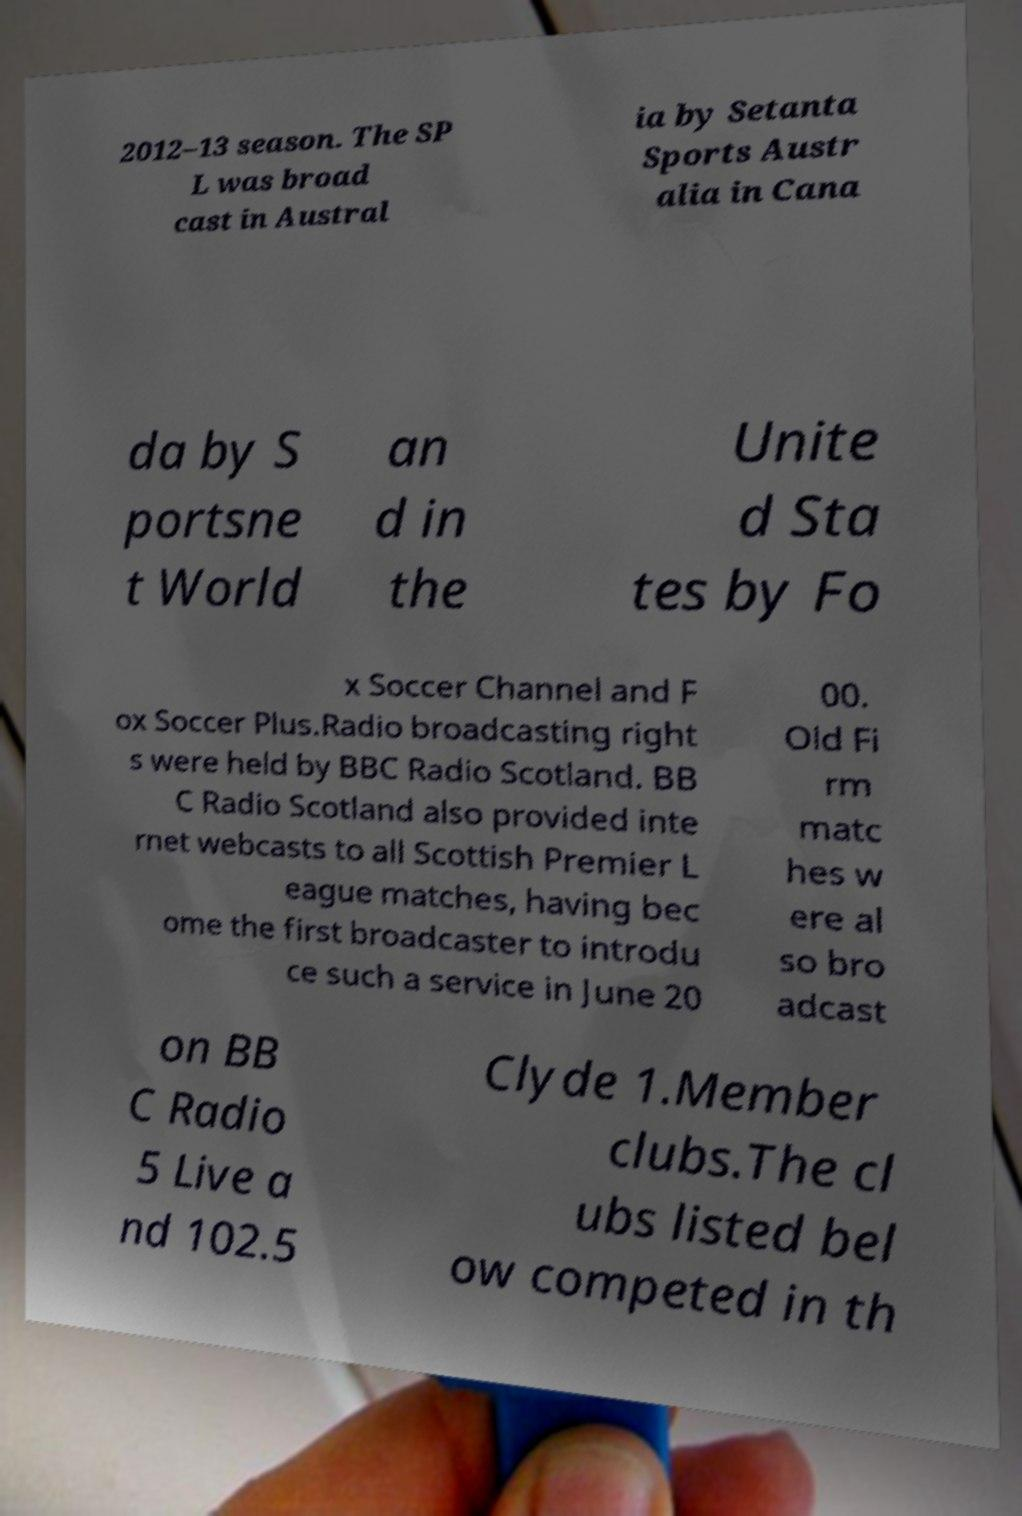Please read and relay the text visible in this image. What does it say? 2012–13 season. The SP L was broad cast in Austral ia by Setanta Sports Austr alia in Cana da by S portsne t World an d in the Unite d Sta tes by Fo x Soccer Channel and F ox Soccer Plus.Radio broadcasting right s were held by BBC Radio Scotland. BB C Radio Scotland also provided inte rnet webcasts to all Scottish Premier L eague matches, having bec ome the first broadcaster to introdu ce such a service in June 20 00. Old Fi rm matc hes w ere al so bro adcast on BB C Radio 5 Live a nd 102.5 Clyde 1.Member clubs.The cl ubs listed bel ow competed in th 